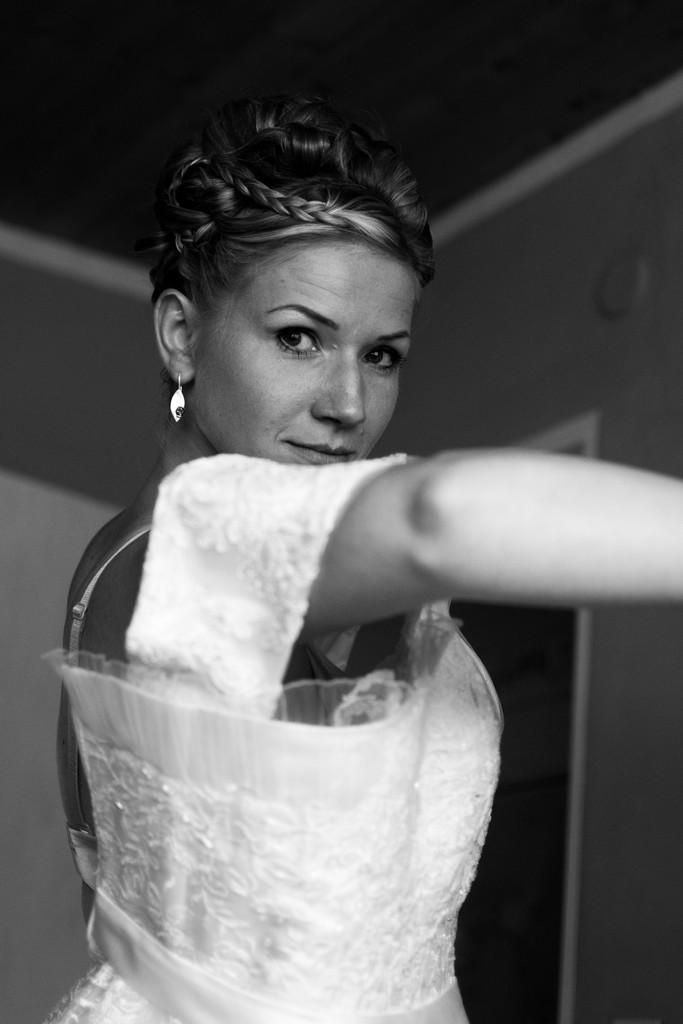What is the main subject of the black and white picture in the image? The main subject of the black and white picture in the image is a woman. What is the woman wearing in the image? The woman is wearing a white dress in the image. What can be seen in the background of the image? There is a wall and a ceiling in the background of the image. What type of fruit is the woman holding in the image? There is no fruit visible in the image; the woman is not holding any fruit. What toys can be seen on the floor in the image? There are no toys present in the image; it only contains a black and white picture of a woman. 